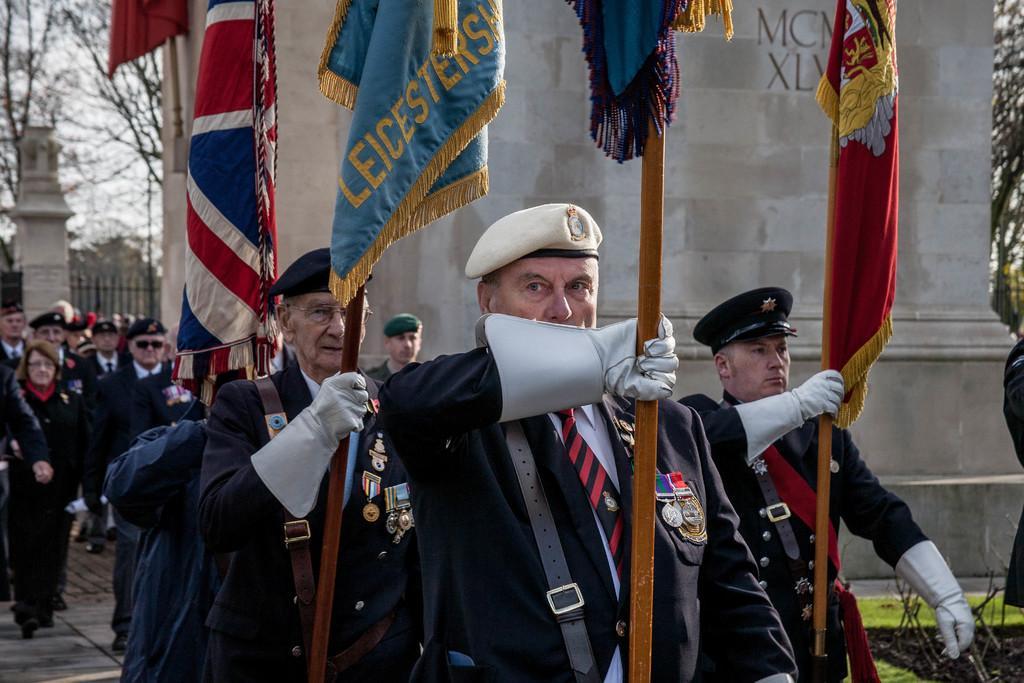Could you give a brief overview of what you see in this image? There is group of persons in black color suits holding flags which are in different colors and walking on the road. In the background, there are other persons in different color dresses walking on the road, there is a building, there is grass on the ground, there are trees, there is a pillar, there is fencing and there is sky. 